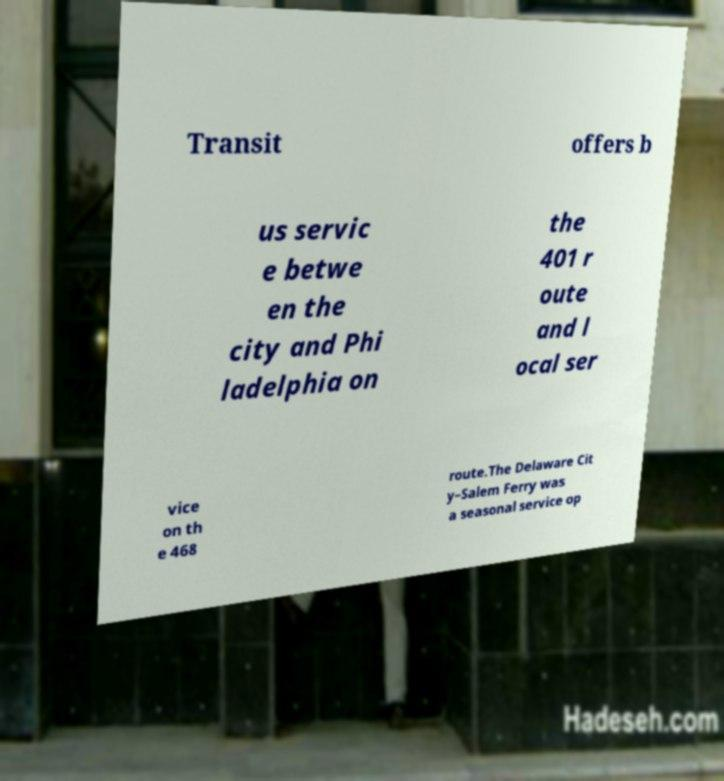Can you accurately transcribe the text from the provided image for me? Transit offers b us servic e betwe en the city and Phi ladelphia on the 401 r oute and l ocal ser vice on th e 468 route.The Delaware Cit y–Salem Ferry was a seasonal service op 